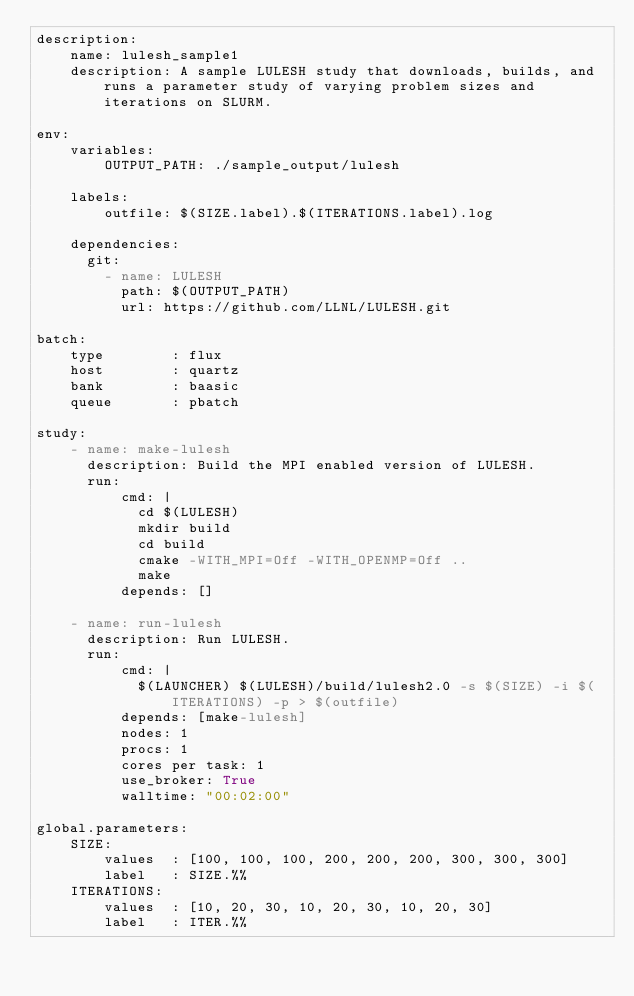<code> <loc_0><loc_0><loc_500><loc_500><_YAML_>description:
    name: lulesh_sample1
    description: A sample LULESH study that downloads, builds, and runs a parameter study of varying problem sizes and iterations on SLURM.

env:
    variables:
        OUTPUT_PATH: ./sample_output/lulesh

    labels:
        outfile: $(SIZE.label).$(ITERATIONS.label).log

    dependencies:
      git:
        - name: LULESH
          path: $(OUTPUT_PATH)
          url: https://github.com/LLNL/LULESH.git

batch:
    type        : flux
    host        : quartz
    bank        : baasic
    queue       : pbatch

study:
    - name: make-lulesh
      description: Build the MPI enabled version of LULESH.
      run:
          cmd: |
            cd $(LULESH)
            mkdir build
            cd build
            cmake -WITH_MPI=Off -WITH_OPENMP=Off ..
            make
          depends: []

    - name: run-lulesh
      description: Run LULESH.
      run:
          cmd: |
            $(LAUNCHER) $(LULESH)/build/lulesh2.0 -s $(SIZE) -i $(ITERATIONS) -p > $(outfile)
          depends: [make-lulesh]
          nodes: 1
          procs: 1
          cores per task: 1
          use_broker: True
          walltime: "00:02:00"

global.parameters:
    SIZE:
        values  : [100, 100, 100, 200, 200, 200, 300, 300, 300]
        label   : SIZE.%%
    ITERATIONS:
        values  : [10, 20, 30, 10, 20, 30, 10, 20, 30]
        label   : ITER.%%
</code> 